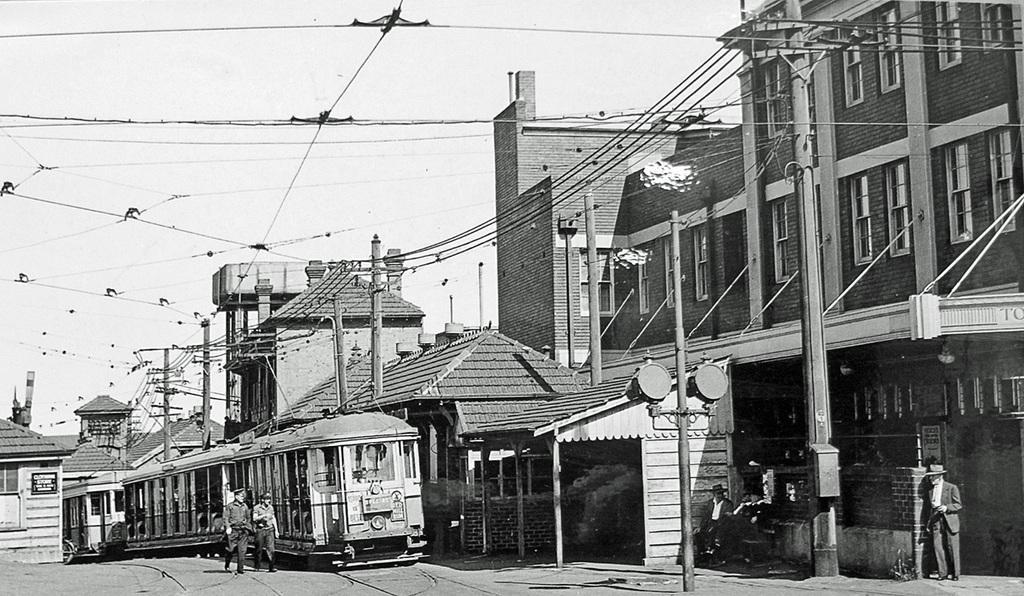Can you describe this image briefly? This is a black and white image. In the center of the image there is a train. There are people walking. To the right side of the image there are houses. At the top of the image there is sky and electric wires and poles. 